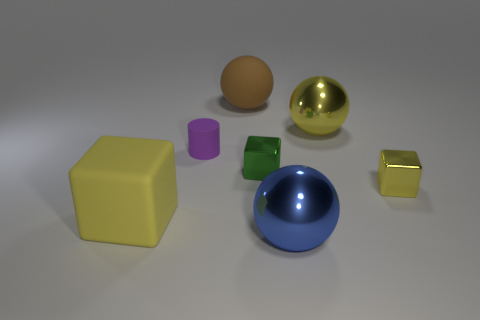What material is the large sphere that is the same color as the large rubber block?
Keep it short and to the point. Metal. How many objects are cyan metallic objects or large things behind the purple object?
Provide a succinct answer. 2. Do the yellow cube that is on the left side of the big brown thing and the blue ball have the same material?
Offer a terse response. No. Is there anything else that has the same size as the yellow metal block?
Your response must be concise. Yes. What is the material of the block on the left side of the tiny thing to the left of the rubber sphere?
Make the answer very short. Rubber. Are there more tiny cubes that are on the right side of the tiny purple cylinder than brown spheres that are right of the brown matte thing?
Your answer should be very brief. Yes. The purple object has what size?
Your answer should be very brief. Small. There is a shiny sphere that is behind the yellow shiny cube; is it the same color as the matte block?
Your response must be concise. Yes. Is there anything else that is the same shape as the large yellow matte thing?
Give a very brief answer. Yes. There is a yellow thing that is left of the brown ball; are there any metallic spheres that are behind it?
Your answer should be very brief. Yes. 